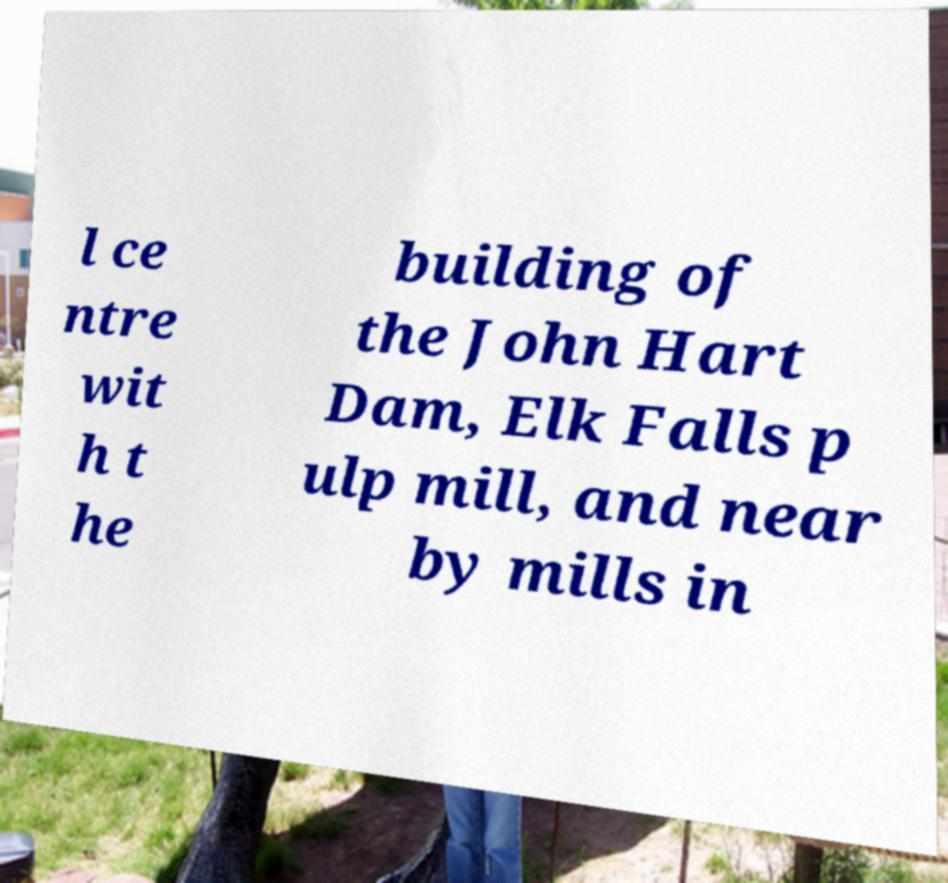Could you extract and type out the text from this image? l ce ntre wit h t he building of the John Hart Dam, Elk Falls p ulp mill, and near by mills in 